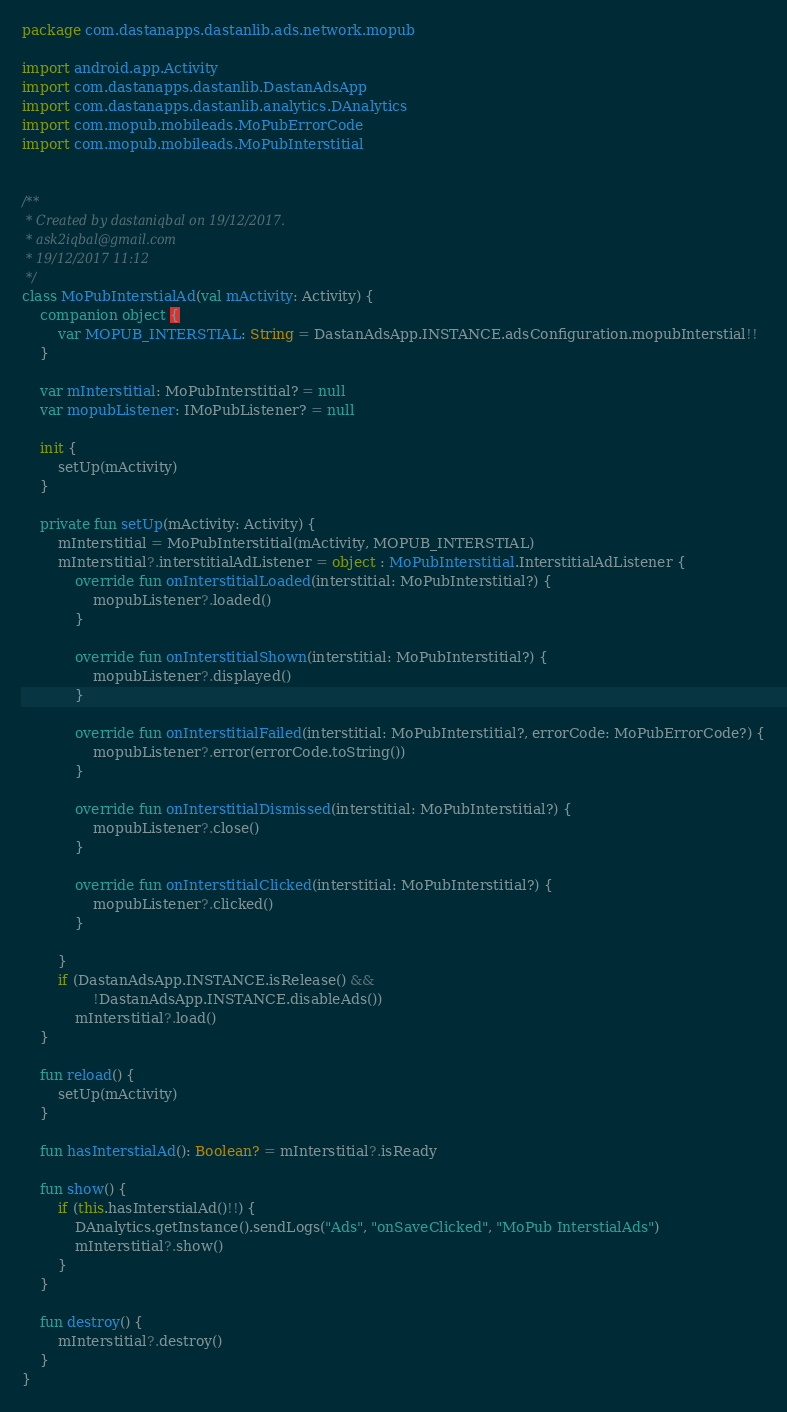<code> <loc_0><loc_0><loc_500><loc_500><_Kotlin_>package com.dastanapps.dastanlib.ads.network.mopub

import android.app.Activity
import com.dastanapps.dastanlib.DastanAdsApp
import com.dastanapps.dastanlib.analytics.DAnalytics
import com.mopub.mobileads.MoPubErrorCode
import com.mopub.mobileads.MoPubInterstitial


/**
 * Created by dastaniqbal on 19/12/2017.
 * ask2iqbal@gmail.com
 * 19/12/2017 11:12
 */
class MoPubInterstialAd(val mActivity: Activity) {
    companion object {
        var MOPUB_INTERSTIAL: String = DastanAdsApp.INSTANCE.adsConfiguration.mopubInterstial!!
    }

    var mInterstitial: MoPubInterstitial? = null
    var mopubListener: IMoPubListener? = null

    init {
        setUp(mActivity)
    }

    private fun setUp(mActivity: Activity) {
        mInterstitial = MoPubInterstitial(mActivity, MOPUB_INTERSTIAL)
        mInterstitial?.interstitialAdListener = object : MoPubInterstitial.InterstitialAdListener {
            override fun onInterstitialLoaded(interstitial: MoPubInterstitial?) {
                mopubListener?.loaded()
            }

            override fun onInterstitialShown(interstitial: MoPubInterstitial?) {
                mopubListener?.displayed()
            }

            override fun onInterstitialFailed(interstitial: MoPubInterstitial?, errorCode: MoPubErrorCode?) {
                mopubListener?.error(errorCode.toString())
            }

            override fun onInterstitialDismissed(interstitial: MoPubInterstitial?) {
                mopubListener?.close()
            }

            override fun onInterstitialClicked(interstitial: MoPubInterstitial?) {
                mopubListener?.clicked()
            }

        }
        if (DastanAdsApp.INSTANCE.isRelease() &&
                !DastanAdsApp.INSTANCE.disableAds())
            mInterstitial?.load()
    }

    fun reload() {
        setUp(mActivity)
    }

    fun hasInterstialAd(): Boolean? = mInterstitial?.isReady

    fun show() {
        if (this.hasInterstialAd()!!) {
            DAnalytics.getInstance().sendLogs("Ads", "onSaveClicked", "MoPub InterstialAds")
            mInterstitial?.show()
        }
    }

    fun destroy() {
        mInterstitial?.destroy()
    }
}</code> 